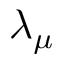Convert formula to latex. <formula><loc_0><loc_0><loc_500><loc_500>\lambda _ { \mu }</formula> 